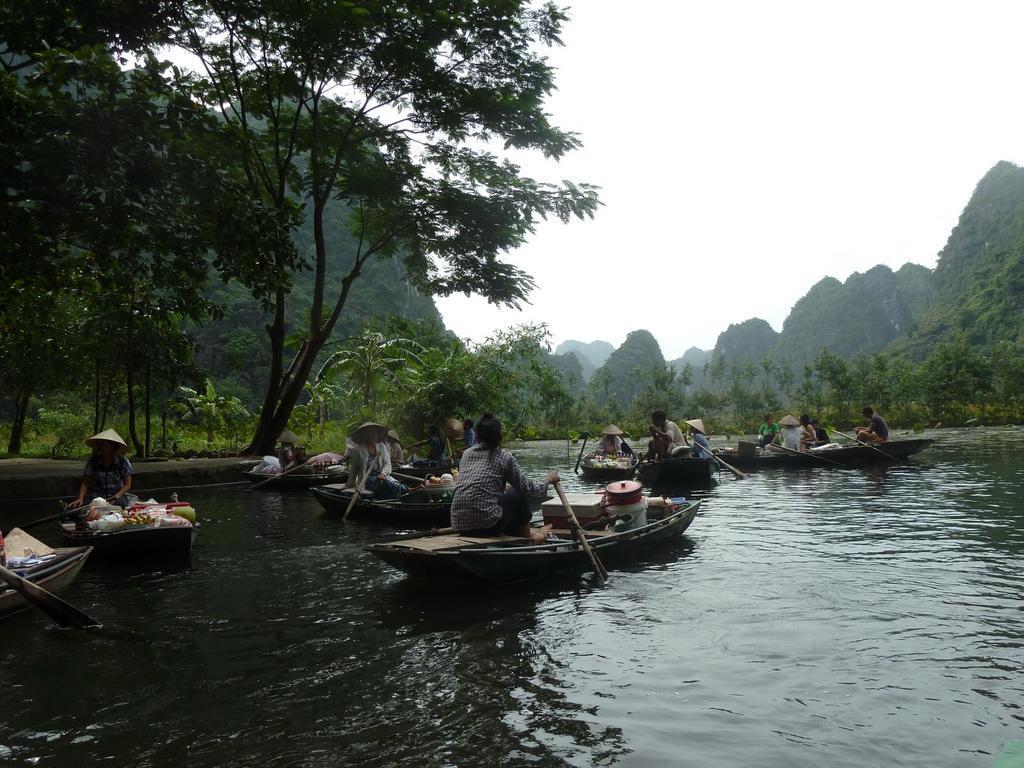Can you describe this image briefly? In this age I can see water in the front and on it I can see number of boats. I can also see number of people are sitting on these boats and I can also see few other stuffs on few boats. In the background I can see number of trees and the sky. 